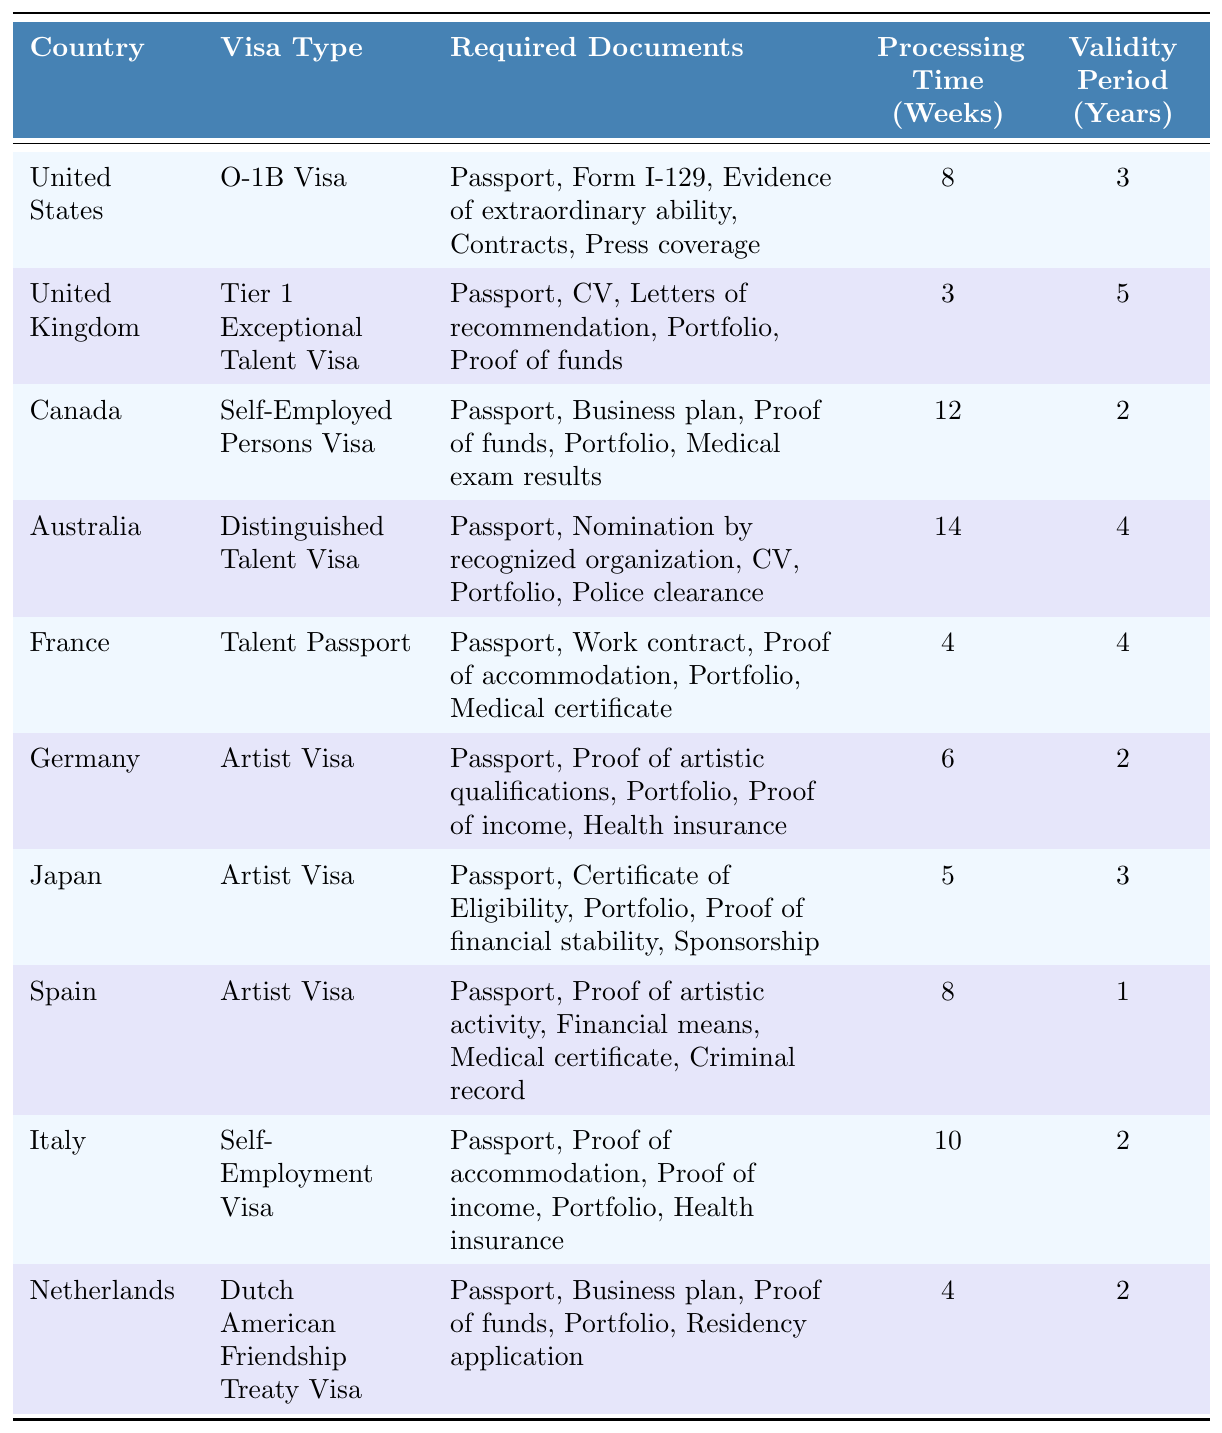What visa type is available for artists in Germany? According to the table, the visa type available for artists in Germany is the "Artist Visa."
Answer: Artist Visa What is the processing time for the Tier 1 Exceptional Talent Visa in the United Kingdom? The processing time for the Tier 1 Exceptional Talent Visa in the United Kingdom is listed as 3 weeks in the table.
Answer: 3 weeks Which country has the longest processing time for artist visas? The table shows that Australia has the longest processing time for artist visas at 14 weeks.
Answer: Australia How many years is the validity period for the O-1B Visa in the United States? The table specifies that the validity period for the O-1B Visa in the United States is 3 years.
Answer: 3 years What are the required documents for obtaining an Artist Visa in Spain? According to the table, the required documents for obtaining an Artist Visa in Spain are: Passport, Proof of artistic activity, Financial means, Medical certificate, and Criminal record.
Answer: Passport, Proof of artistic activity, Financial means, Medical certificate, Criminal record What is the average validity period for the artist visas listed in the table? To calculate the average, we sum the validity periods (2 + 2 + 3 + 1 + 2) for the artist visas (Germany, Japan, Spain, Italy) which equals 10, then divide by the number of artist visas (5), giving us an average of 2 years.
Answer: 2 years Is the Talent Passport for France valid for more than 2 years? The validity period for the Talent Passport in France is 4 years, which is more than 2 years.
Answer: Yes How many countries offer an artist visa as per this table? The table indicates that there are 5 countries offering an artist visa: Germany, Japan, Spain, Italy, and the Netherlands.
Answer: 5 countries What is the total processing time for the Artist Visas in Germany, Japan, and Spain? The processing times for these artist visas are 6 weeks (Germany), 5 weeks (Japan), and 8 weeks (Spain). Adding them together gives us a total of 19 weeks.
Answer: 19 weeks Which country has the shortest processing time for obtaining a visa for artists? The table shows that the United Kingdom has the shortest processing time for obtaining a visa for artists at 3 weeks.
Answer: United Kingdom 